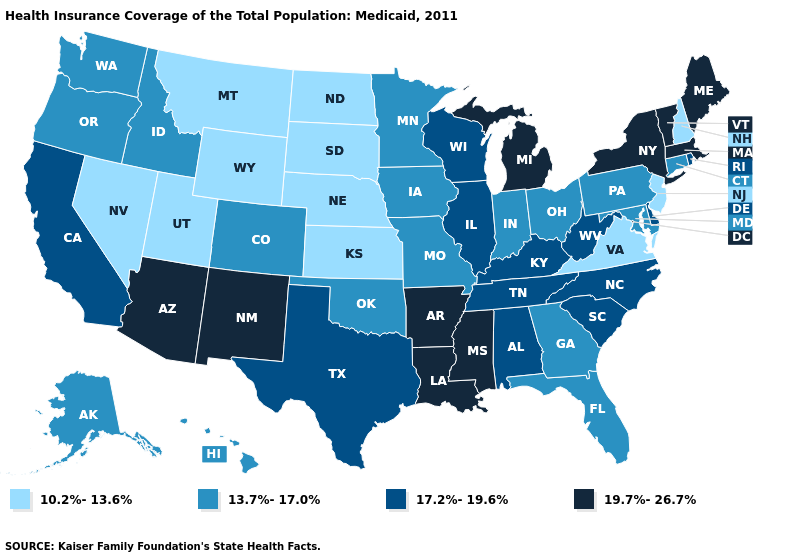Name the states that have a value in the range 19.7%-26.7%?
Short answer required. Arizona, Arkansas, Louisiana, Maine, Massachusetts, Michigan, Mississippi, New Mexico, New York, Vermont. Among the states that border Montana , does Idaho have the lowest value?
Write a very short answer. No. Is the legend a continuous bar?
Short answer required. No. Among the states that border Wisconsin , does Michigan have the lowest value?
Answer briefly. No. What is the highest value in the West ?
Be succinct. 19.7%-26.7%. Name the states that have a value in the range 19.7%-26.7%?
Give a very brief answer. Arizona, Arkansas, Louisiana, Maine, Massachusetts, Michigan, Mississippi, New Mexico, New York, Vermont. Does the map have missing data?
Quick response, please. No. Among the states that border Vermont , which have the highest value?
Answer briefly. Massachusetts, New York. Does Ohio have the lowest value in the USA?
Quick response, please. No. Name the states that have a value in the range 17.2%-19.6%?
Answer briefly. Alabama, California, Delaware, Illinois, Kentucky, North Carolina, Rhode Island, South Carolina, Tennessee, Texas, West Virginia, Wisconsin. What is the highest value in the MidWest ?
Answer briefly. 19.7%-26.7%. Does California have a lower value than Idaho?
Be succinct. No. Which states have the highest value in the USA?
Write a very short answer. Arizona, Arkansas, Louisiana, Maine, Massachusetts, Michigan, Mississippi, New Mexico, New York, Vermont. Among the states that border Minnesota , which have the lowest value?
Short answer required. North Dakota, South Dakota. Which states have the highest value in the USA?
Write a very short answer. Arizona, Arkansas, Louisiana, Maine, Massachusetts, Michigan, Mississippi, New Mexico, New York, Vermont. 